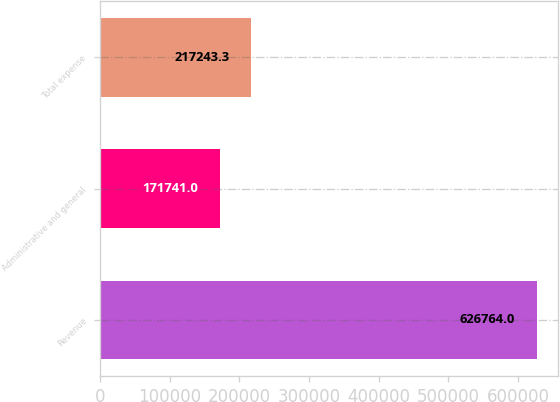Convert chart. <chart><loc_0><loc_0><loc_500><loc_500><bar_chart><fcel>Revenue<fcel>Administrative and general<fcel>Total expense<nl><fcel>626764<fcel>171741<fcel>217243<nl></chart> 